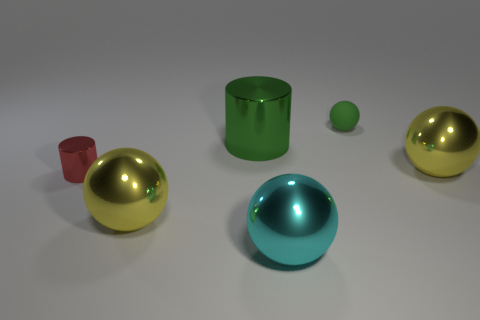What is the color of the other shiny thing that is the same shape as the green metallic thing?
Your answer should be very brief. Red. What is the material of the cylinder that is the same color as the tiny sphere?
Your answer should be very brief. Metal. What size is the metal thing that is the same color as the small matte ball?
Your response must be concise. Large. Are there any large cylinders of the same color as the small matte object?
Provide a succinct answer. Yes. There is a tiny cylinder in front of the matte object; are there any balls that are behind it?
Your answer should be compact. Yes. Is the size of the cyan object the same as the yellow thing that is in front of the tiny red shiny thing?
Offer a terse response. Yes. Is there a object that is behind the sphere that is in front of the yellow thing to the left of the green cylinder?
Your response must be concise. Yes. What is the tiny object that is behind the tiny red metallic cylinder made of?
Provide a short and direct response. Rubber. Do the red metal object and the green sphere have the same size?
Your answer should be compact. Yes. There is a big object that is behind the red metal cylinder and in front of the large cylinder; what is its color?
Make the answer very short. Yellow. 